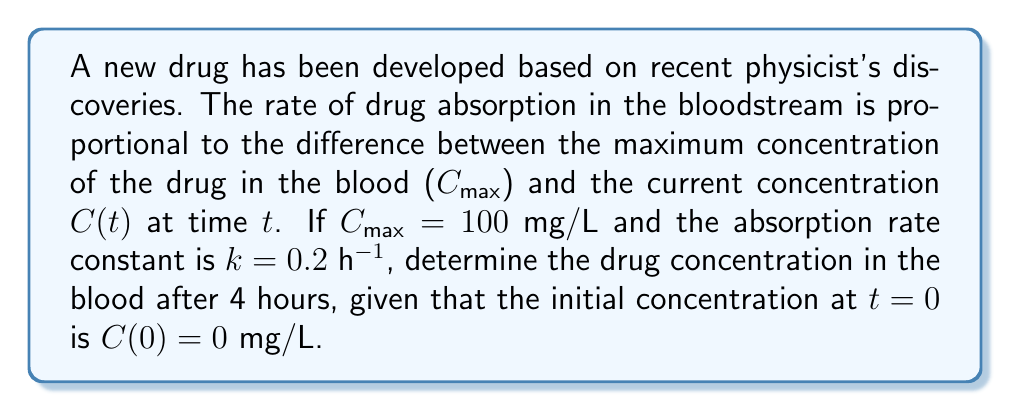Could you help me with this problem? 1. The rate of change of drug concentration can be modeled by the differential equation:

   $$\frac{dC}{dt} = k(C_{max} - C)$$

2. This is a first-order linear differential equation. We can solve it as follows:

   $$\frac{dC}{C_{max} - C} = k dt$$

3. Integrating both sides:

   $$-\ln|C_{max} - C| = kt + A$$

   where $A$ is the constant of integration.

4. Applying the initial condition $C(0) = 0$:

   $$-\ln|C_{max} - 0| = k(0) + A$$
   $$-\ln(C_{max}) = A$$

5. Substituting back:

   $$-\ln|C_{max} - C| = kt - \ln(C_{max})$$

6. Solving for $C$:

   $$C = C_{max}(1 - e^{-kt})$$

7. Now we can substitute the given values:
   $C_{max} = 100$ mg/L, $k = 0.2$ h⁻¹, $t = 4$ h

   $$C(4) = 100(1 - e^{-0.2 \cdot 4})$$
   $$C(4) = 100(1 - e^{-0.8})$$
   $$C(4) = 100(1 - 0.4493)$$
   $$C(4) = 55.07$$ mg/L
Answer: 55.07 mg/L 